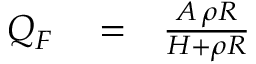Convert formula to latex. <formula><loc_0><loc_0><loc_500><loc_500>\begin{array} { r l r } { Q _ { F } } & = } & { \frac { A \, \rho R } { H + \rho R } } \end{array}</formula> 